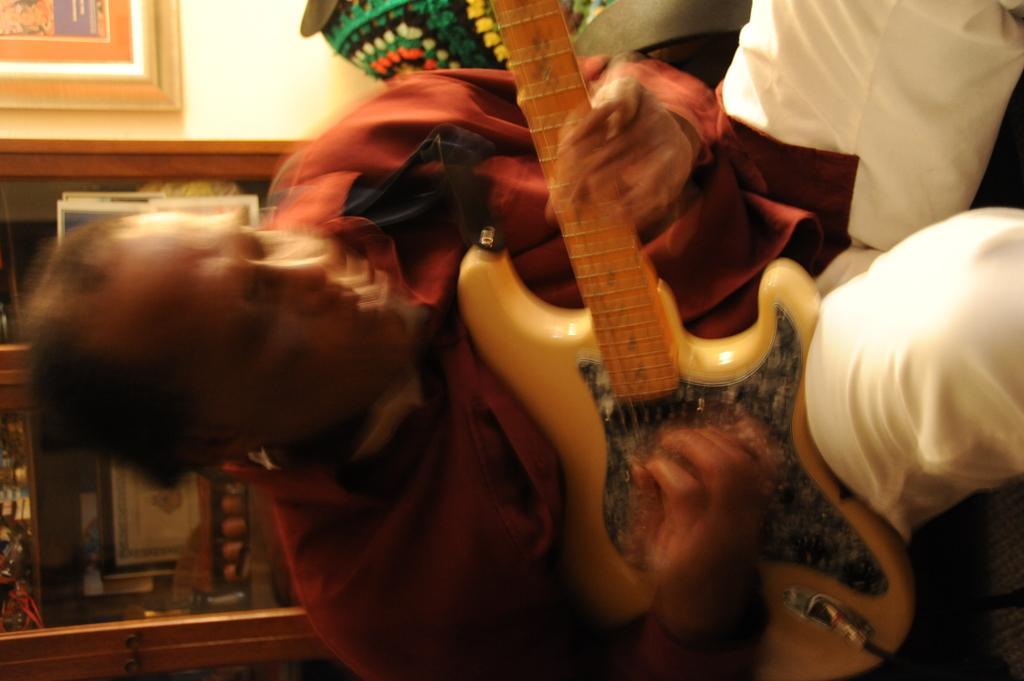Describe this image in one or two sentences. In this image there is a man playing a guitar with his hands, in the background there is wall to that wall there is a cupboard in that cupboard there are objects. 